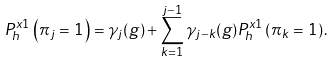Convert formula to latex. <formula><loc_0><loc_0><loc_500><loc_500>P _ { h } ^ { x 1 } \left ( \pi _ { j } = 1 \right ) = \gamma _ { j } ( g ) + \sum _ { k = 1 } ^ { j - 1 } \gamma _ { j - k } ( g ) P _ { h } ^ { x 1 } \left ( \pi _ { k } = 1 \right ) .</formula> 